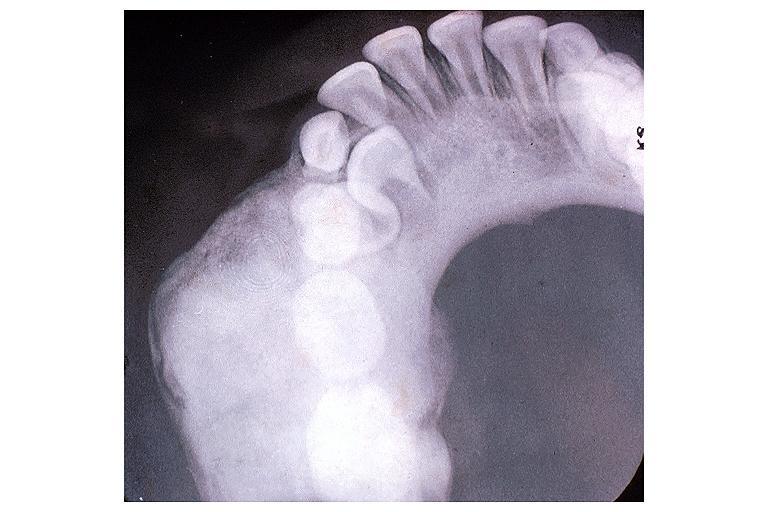s excellent example case present?
Answer the question using a single word or phrase. No 